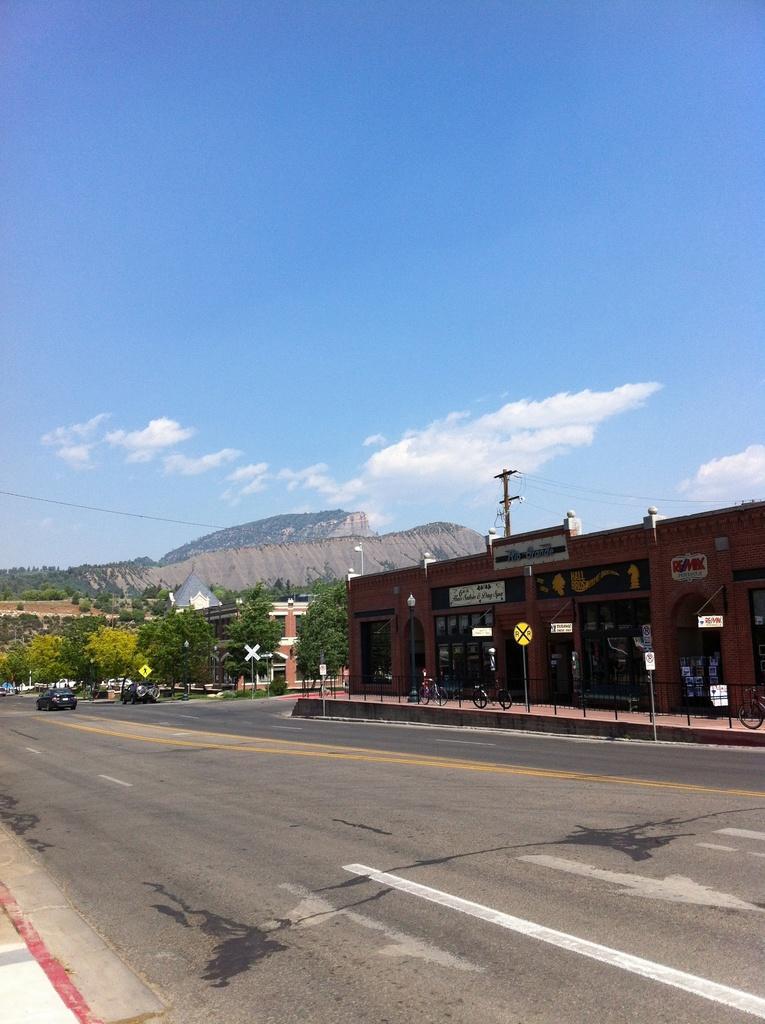In one or two sentences, can you explain what this image depicts? In this image we can see a building in front of it a bicycle parked on the path ,group of poles and in the background ,we can see group of trees ,cars parked on the road ,mountains ,and a cloudy sky. 